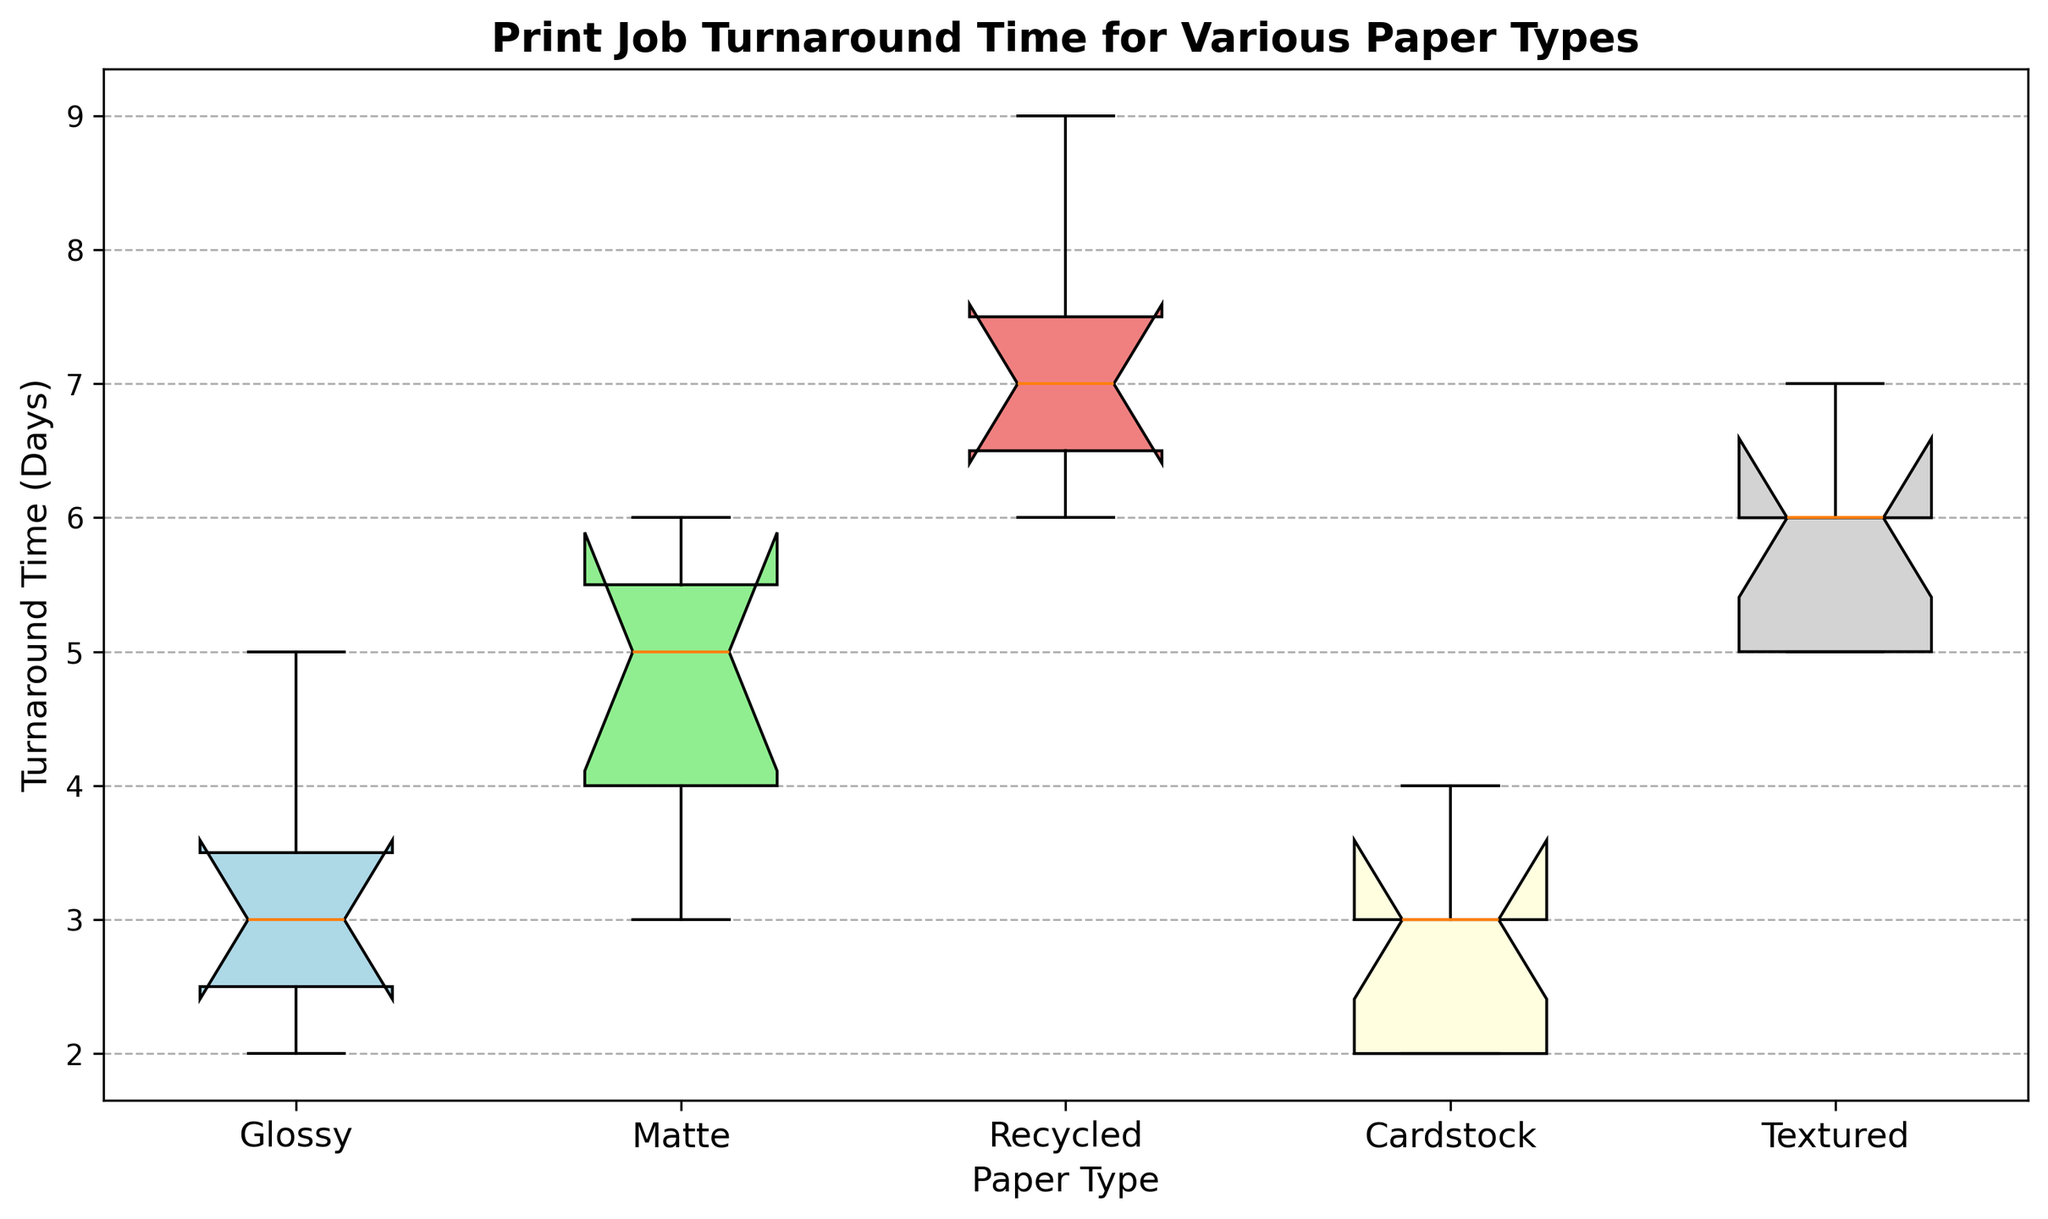What's the median turnaround time for Glossy paper? First, find the sorted times for Glossy paper: [2, 2, 3, 3, 3, 4, 5]. The median (middle value) is the 4th value.
Answer: 3 Which paper type has the highest variability in turnaround time? Look at the spread of the box plots. The largest spread (distance between the lower and upper extremes) indicates the highest variability. Recycled paper has the widest spread.
Answer: Recycled What is the interquartile range (IQR) for Textured paper? The IQR is the range between the first quartile (25th percentile) and the third quartile (75th percentile). For Textured paper, estimate the positions visually, which are around 5 and 6 respectively. The IQR is 6 - 5.
Answer: 1 Which paper type has the lowest median turnaround time? Look at the median lines drawn within each box. The lowest median line corresponds to Cardstock paper.
Answer: Cardstock How many days separate the minimum and maximum turnaround times for Recycled paper? The minimum appears to be 6 and the maximum 9. 9 - 6 is 3 days.
Answer: 3 Compare the medians of Glossy and Matte papers. Which is greater? The median of Glossy paper is 3, while the median of Matte paper is 5. Matte paper has a greater median.
Answer: Matte Is there any overlap in the interquartile ranges of Glossy and Cardstock papers? Look at the boxes representing the IQRs (middle 50% of the data). Glossy spans from 2 to 4, and Cardstock also spans from 2 to approximately 3. Yes, there is an overlap.
Answer: Yes How does the range of turnaround times for Matte paper compare to that of Textured paper? The range for Matte is 6 - 3 = 3, and the range for Textured is 7 - 5 = 2. Matte has a larger range.
Answer: Matte What is the upper hinge (third quartile) for Recycled paper? Estimate visually where the top of the box (third quartile) is for Recycled paper, which is around 7.
Answer: 7 